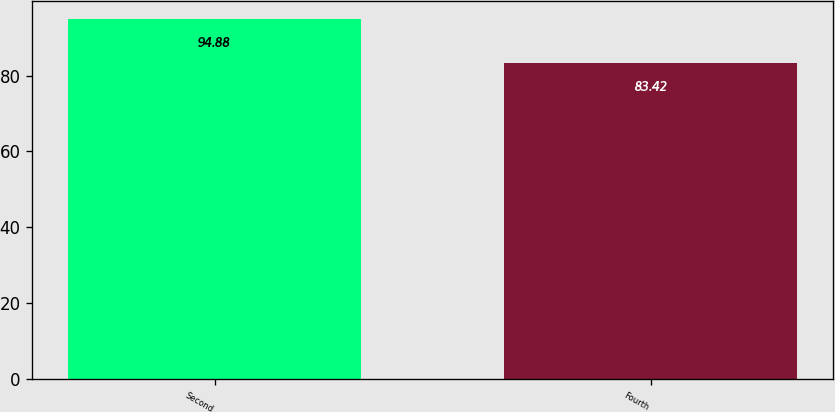<chart> <loc_0><loc_0><loc_500><loc_500><bar_chart><fcel>Second<fcel>Fourth<nl><fcel>94.88<fcel>83.42<nl></chart> 